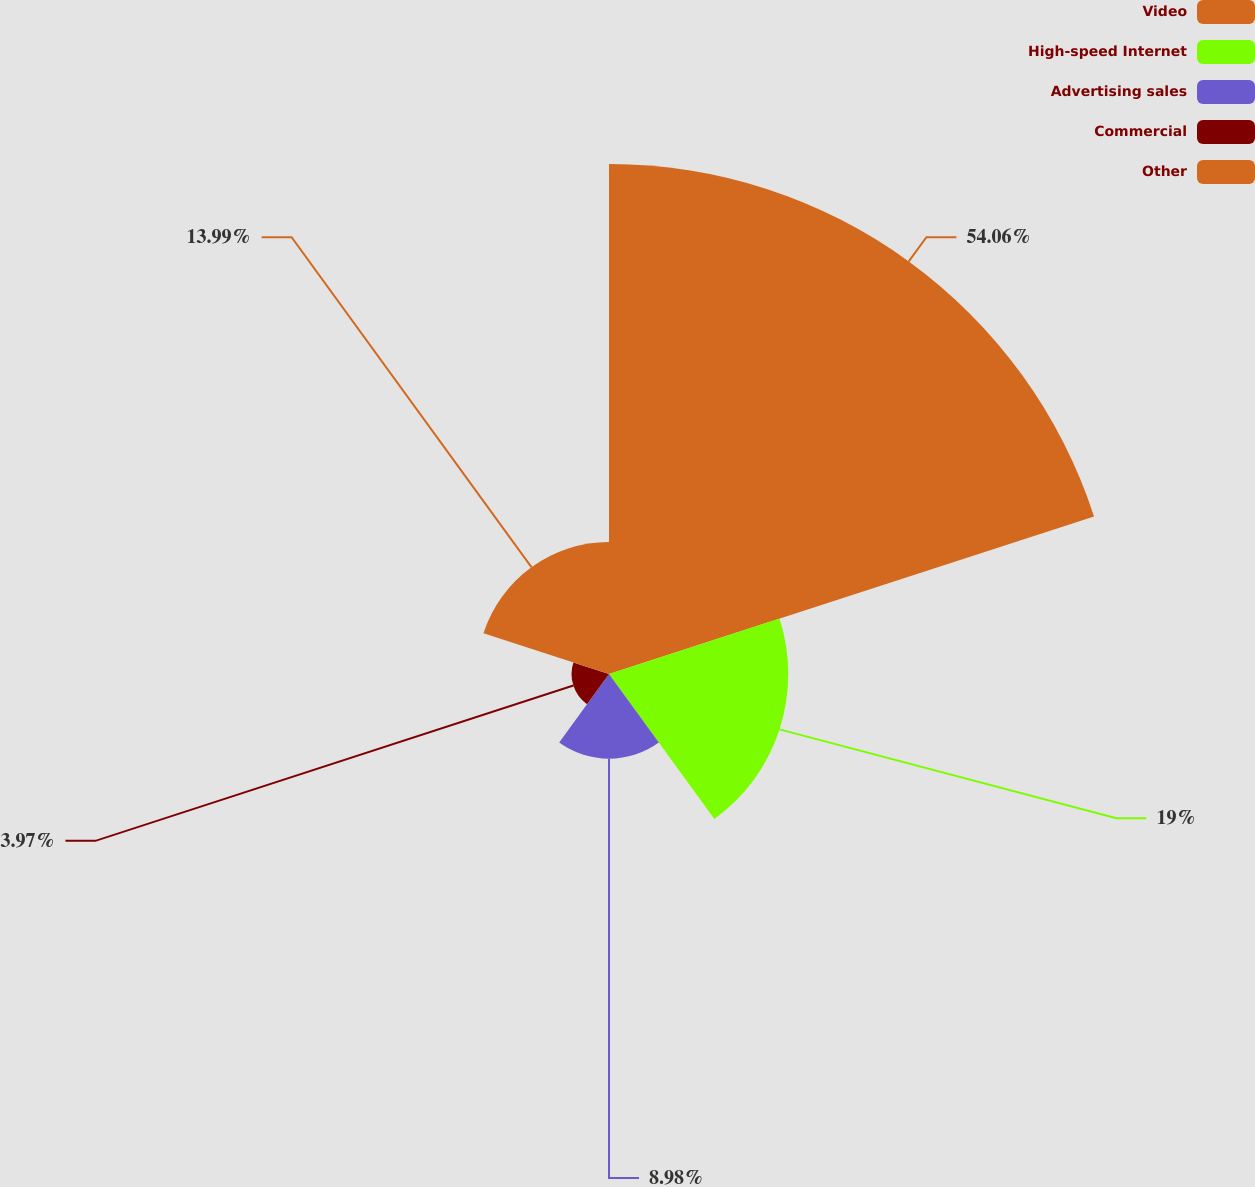Convert chart. <chart><loc_0><loc_0><loc_500><loc_500><pie_chart><fcel>Video<fcel>High-speed Internet<fcel>Advertising sales<fcel>Commercial<fcel>Other<nl><fcel>54.05%<fcel>19.0%<fcel>8.98%<fcel>3.97%<fcel>13.99%<nl></chart> 